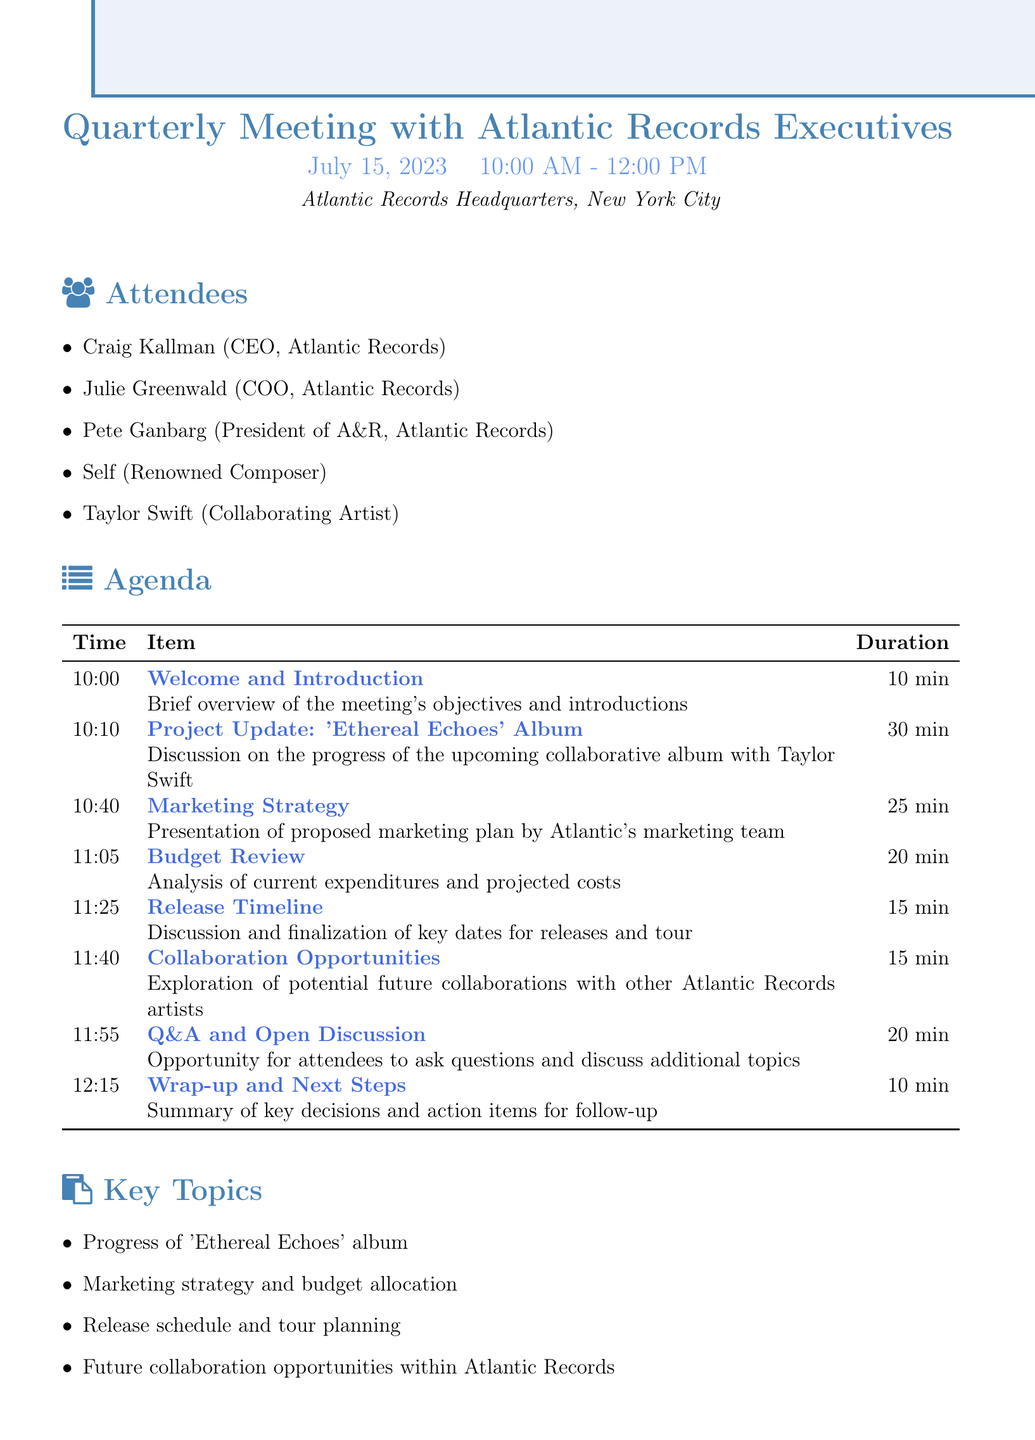What is the meeting title? The meeting title is found at the beginning of the document under the "Quarterly Meeting" section.
Answer: Quarterly Meeting with Atlantic Records Executives Who is the collaborating artist for the upcoming album? The collaborating artist's name is mentioned in the agenda under "Project Update."
Answer: Taylor Swift What is the duration allocated for the Marketing Strategy discussion? The duration can be found in the agenda table that outlines each item's time allocation.
Answer: 25 minutes What is one key topic discussed during the meeting? The key topics are listed in a separate section of the document.
Answer: Progress of 'Ethereal Echoes' album How many attendees are listed for the meeting? The number of attendees can be counted from the "Attendees" section in the document.
Answer: Five 